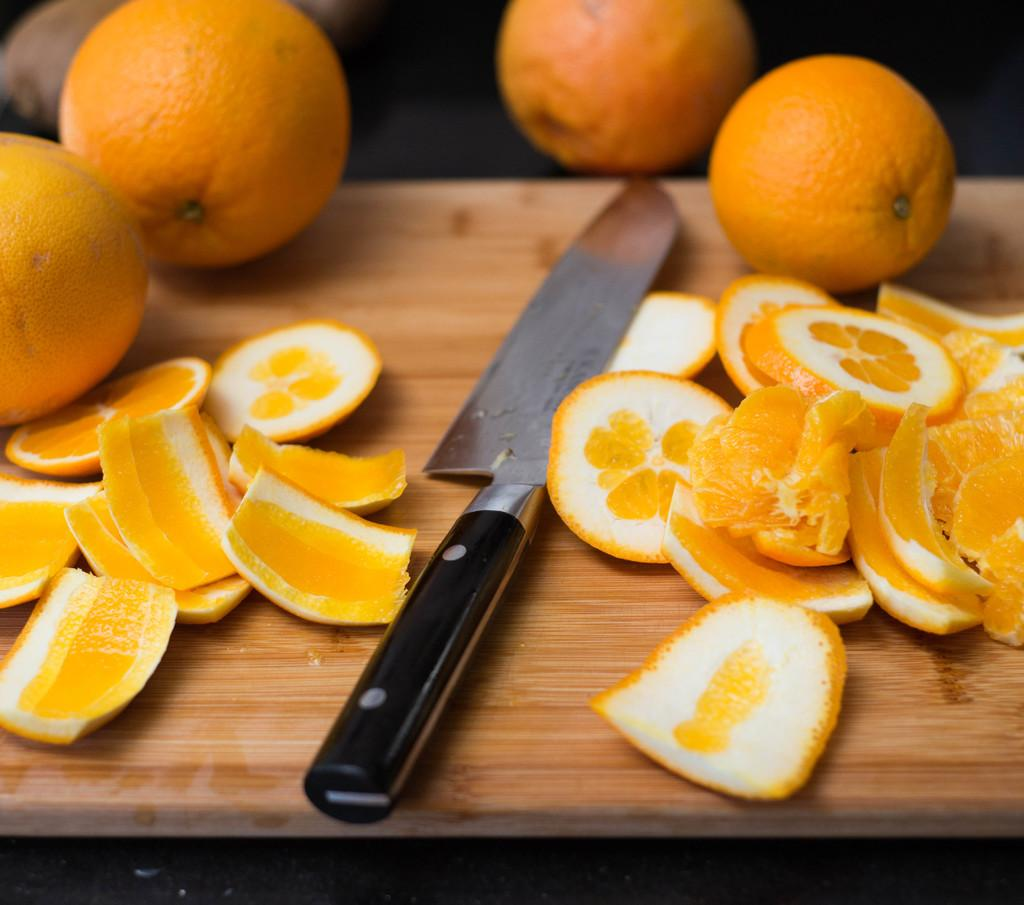What type of fruit is present in the image? There is a group of oranges in the image. How are the oranges arranged in the image? The oranges are placed on a wooden board. What utensil can be seen in the image? There is a knife in the image. What type of lamp is present in the image? There is no lamp present in the image; it features a group of oranges on a wooden board and a knife. How does the stamp affect the oranges in the image? There is no stamp present in the image, so it cannot affect the oranges. 